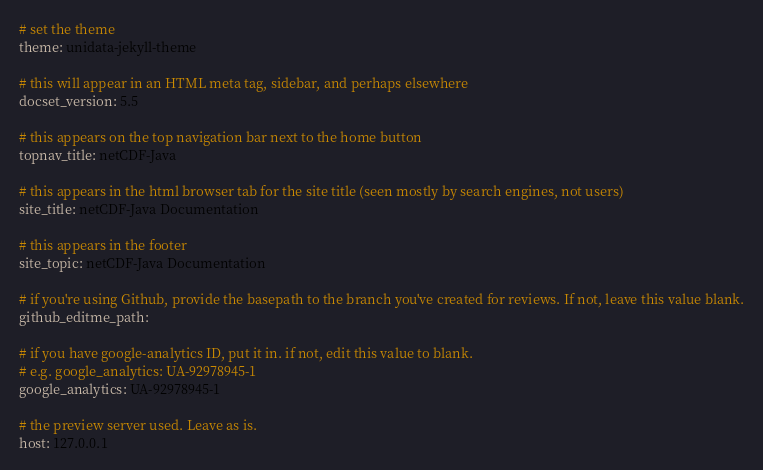<code> <loc_0><loc_0><loc_500><loc_500><_YAML_># set the theme
theme: unidata-jekyll-theme

# this will appear in an HTML meta tag, sidebar, and perhaps elsewhere
docset_version: 5.5

# this appears on the top navigation bar next to the home button
topnav_title: netCDF-Java

# this appears in the html browser tab for the site title (seen mostly by search engines, not users)
site_title: netCDF-Java Documentation

# this appears in the footer
site_topic: netCDF-Java Documentation

# if you're using Github, provide the basepath to the branch you've created for reviews. If not, leave this value blank.
github_editme_path:

# if you have google-analytics ID, put it in. if not, edit this value to blank.
# e.g. google_analytics: UA-92978945-1
google_analytics: UA-92978945-1

# the preview server used. Leave as is.
host: 127.0.0.1
</code> 